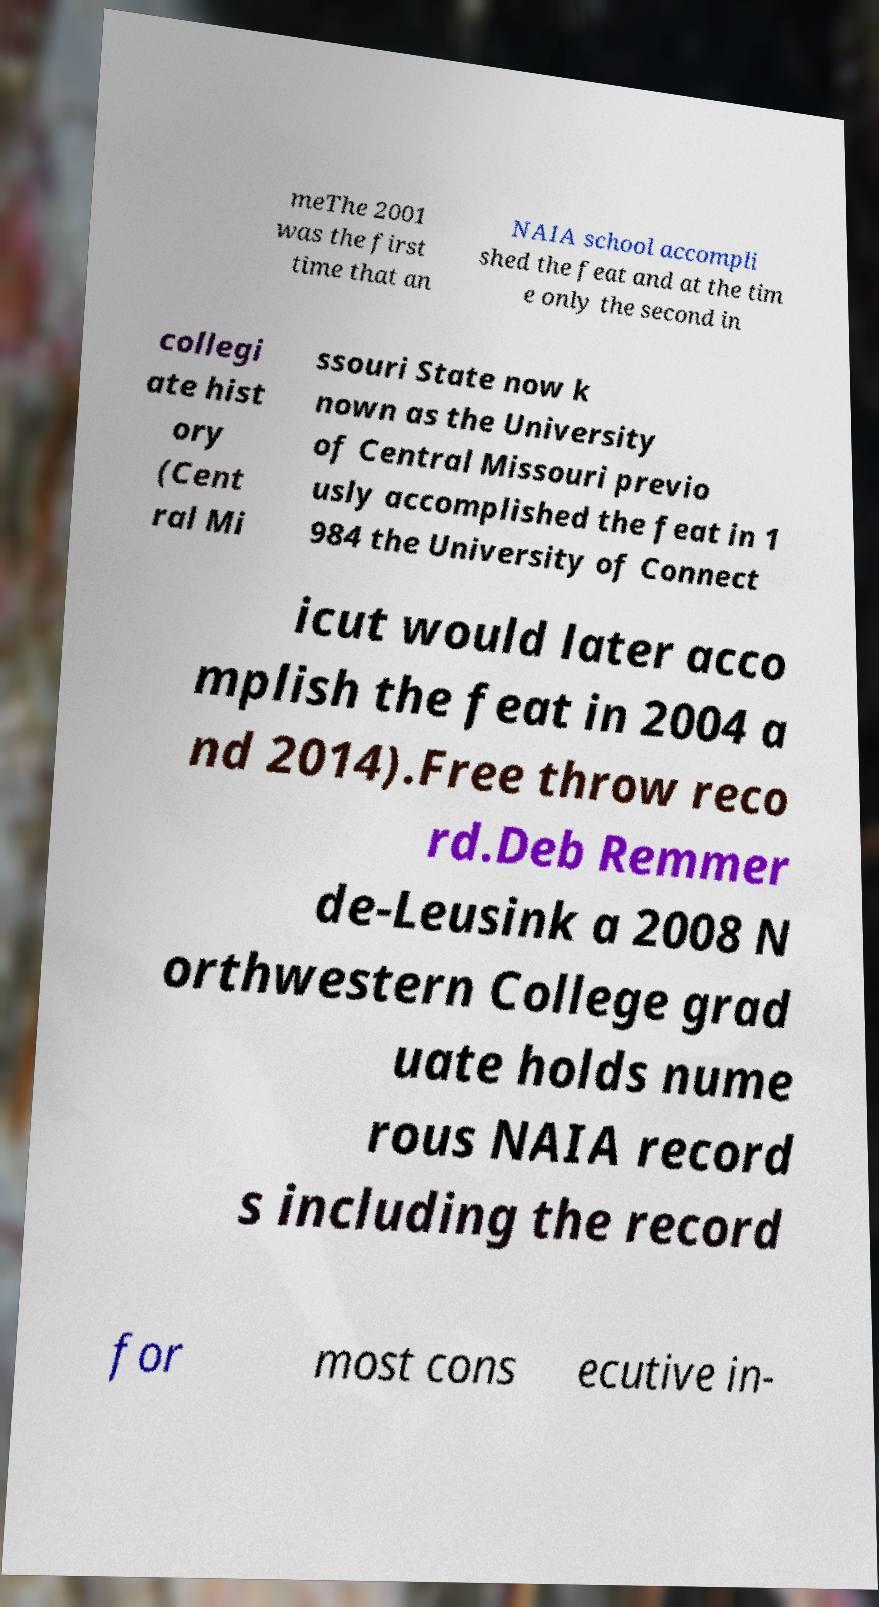There's text embedded in this image that I need extracted. Can you transcribe it verbatim? meThe 2001 was the first time that an NAIA school accompli shed the feat and at the tim e only the second in collegi ate hist ory (Cent ral Mi ssouri State now k nown as the University of Central Missouri previo usly accomplished the feat in 1 984 the University of Connect icut would later acco mplish the feat in 2004 a nd 2014).Free throw reco rd.Deb Remmer de-Leusink a 2008 N orthwestern College grad uate holds nume rous NAIA record s including the record for most cons ecutive in- 